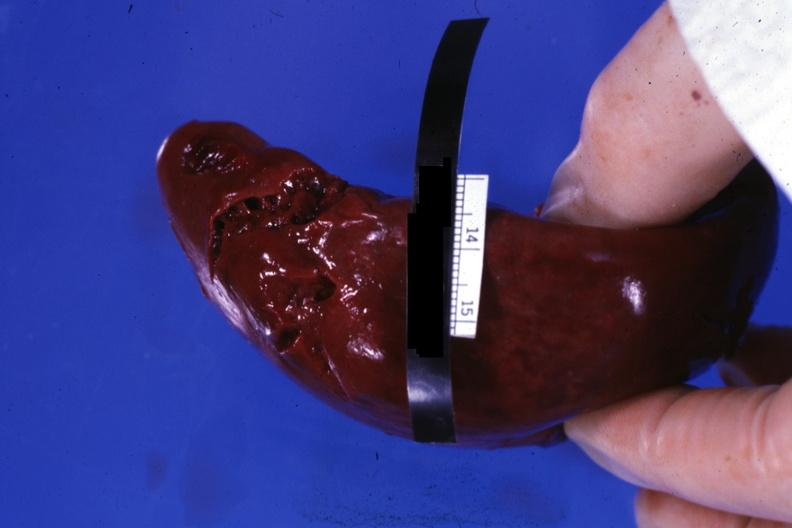what done external view of lacerations of capsule done during?
Answer the question using a single word or phrase. Done surgical procedure 